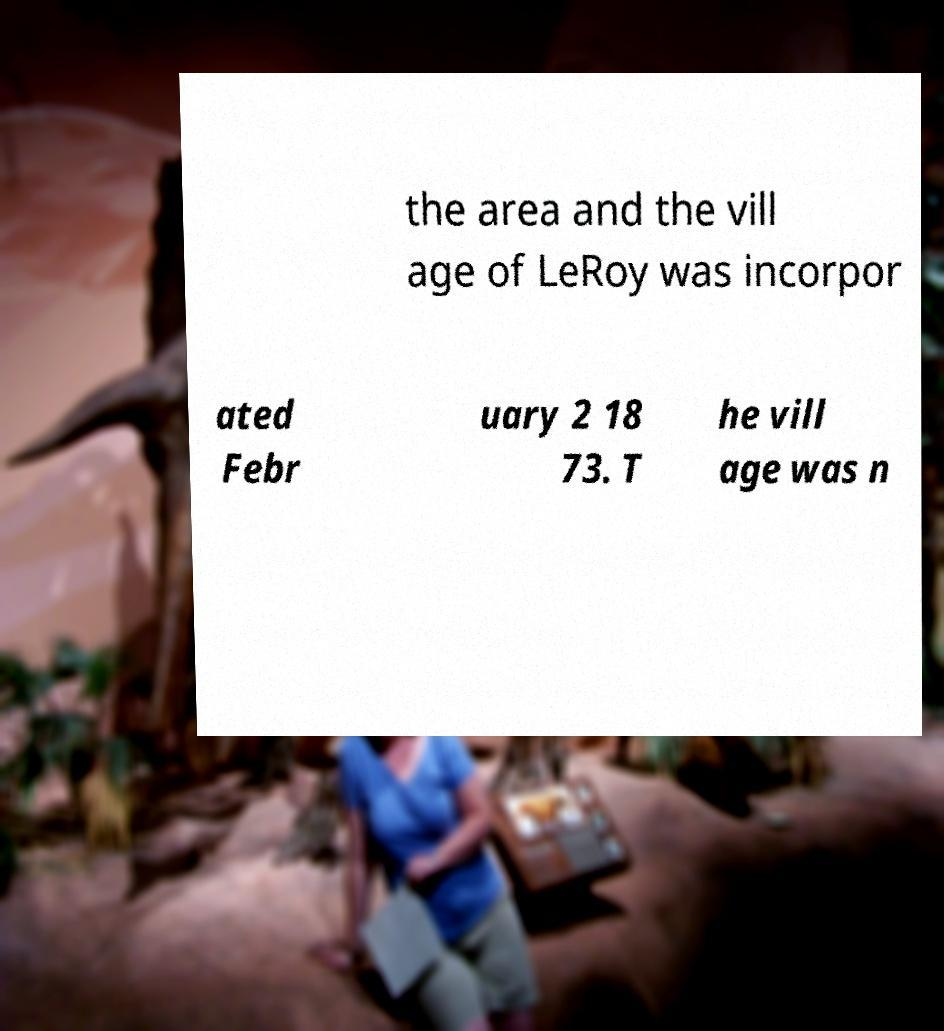Please identify and transcribe the text found in this image. the area and the vill age of LeRoy was incorpor ated Febr uary 2 18 73. T he vill age was n 